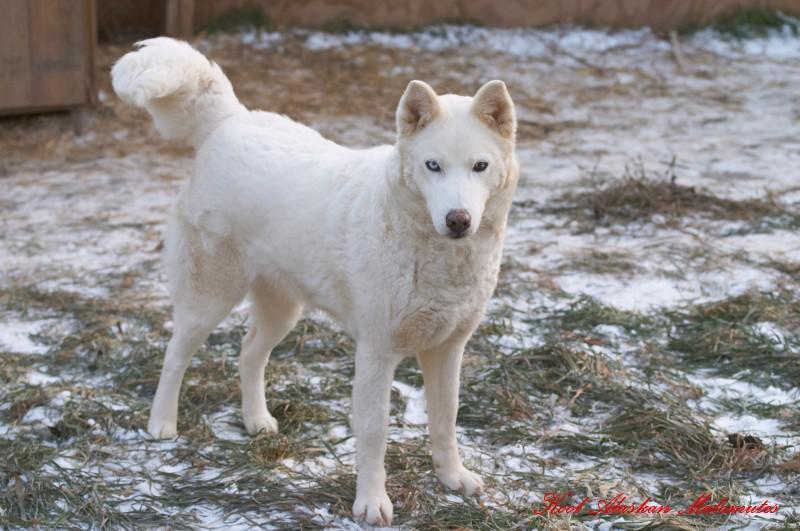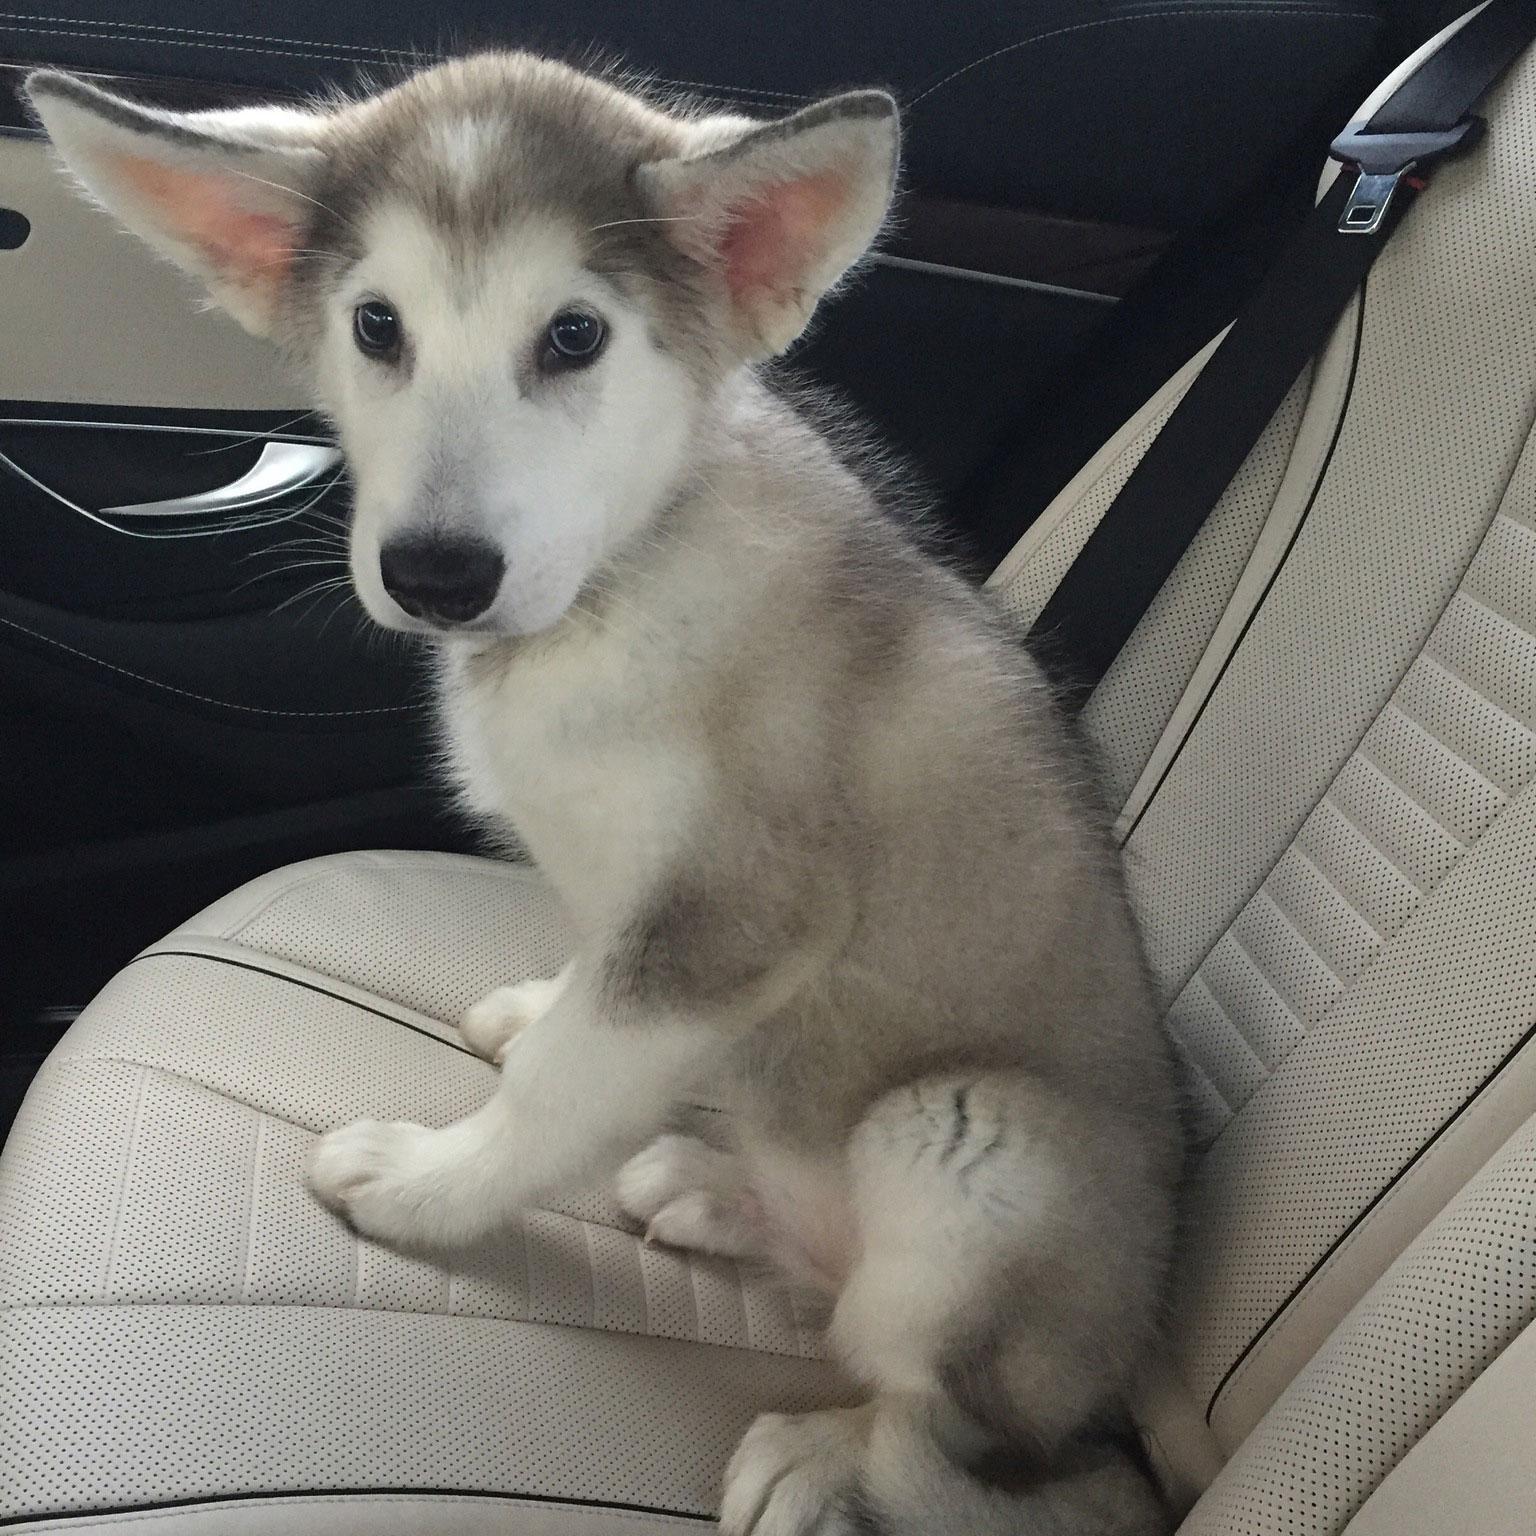The first image is the image on the left, the second image is the image on the right. Evaluate the accuracy of this statement regarding the images: "There are exactly two dogs in total.". Is it true? Answer yes or no. Yes. The first image is the image on the left, the second image is the image on the right. For the images displayed, is the sentence "A dog has its tongue out." factually correct? Answer yes or no. No. 